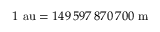Convert formula to latex. <formula><loc_0><loc_0><loc_500><loc_500>1 { a u } = 1 4 9 \, 5 9 7 \, 8 7 0 \, 7 0 0 { m }</formula> 